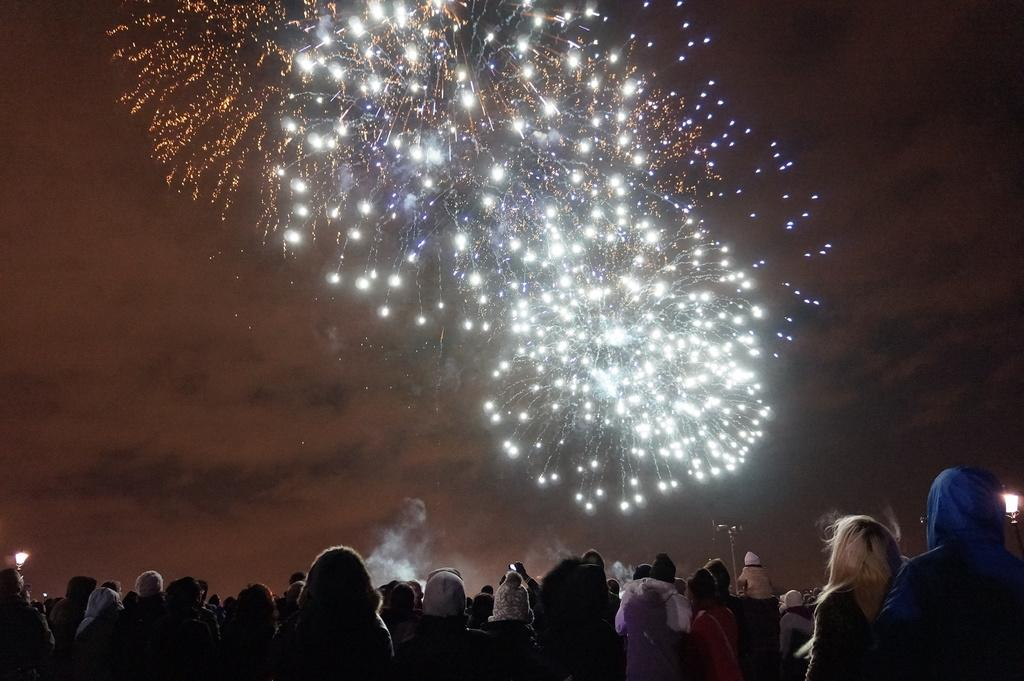What can be seen at the bottom of the image? There are people standing at the bottom of the image. What objects are present in the image besides the people? There are poles and lights in the image. What is happening in the sky in the background of the image? Fireworks are visible in the sky in the background of the image. What type of print can be seen on the branch in the image? There is no branch or print present in the image. How does the crack in the image affect the people standing at the bottom? There is no crack present in the image, so it does not affect the people standing at the bottom. 